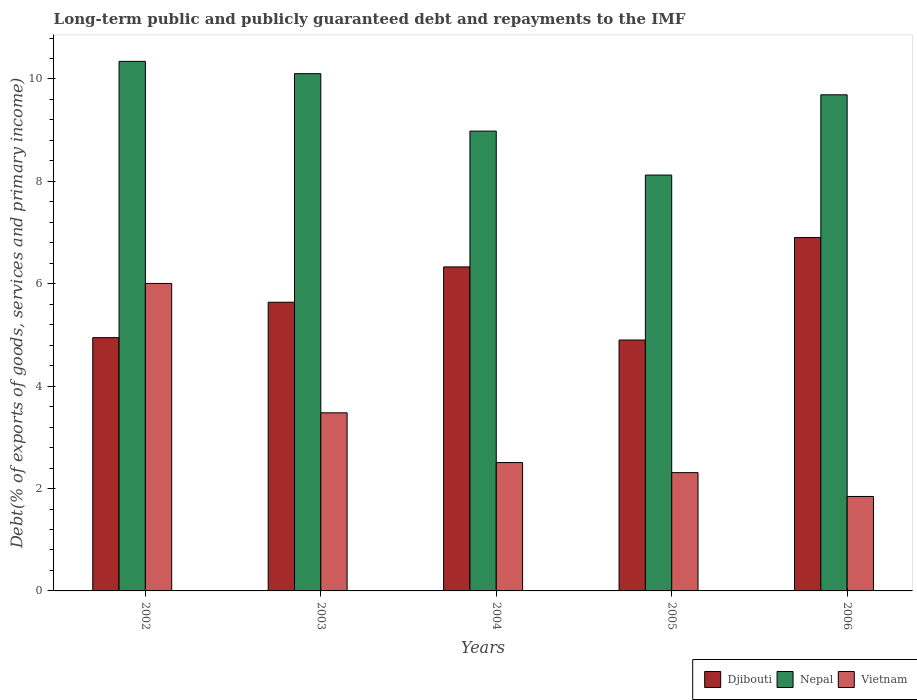How many different coloured bars are there?
Ensure brevity in your answer.  3. Are the number of bars per tick equal to the number of legend labels?
Make the answer very short. Yes. Are the number of bars on each tick of the X-axis equal?
Offer a terse response. Yes. How many bars are there on the 2nd tick from the left?
Your response must be concise. 3. How many bars are there on the 2nd tick from the right?
Provide a short and direct response. 3. What is the label of the 2nd group of bars from the left?
Make the answer very short. 2003. In how many cases, is the number of bars for a given year not equal to the number of legend labels?
Offer a very short reply. 0. What is the debt and repayments in Vietnam in 2005?
Your answer should be very brief. 2.31. Across all years, what is the maximum debt and repayments in Vietnam?
Your answer should be very brief. 6.01. Across all years, what is the minimum debt and repayments in Nepal?
Give a very brief answer. 8.12. What is the total debt and repayments in Vietnam in the graph?
Your answer should be very brief. 16.15. What is the difference between the debt and repayments in Nepal in 2003 and that in 2005?
Keep it short and to the point. 1.98. What is the difference between the debt and repayments in Nepal in 2002 and the debt and repayments in Vietnam in 2004?
Offer a terse response. 7.84. What is the average debt and repayments in Djibouti per year?
Make the answer very short. 5.74. In the year 2004, what is the difference between the debt and repayments in Nepal and debt and repayments in Vietnam?
Your answer should be very brief. 6.47. What is the ratio of the debt and repayments in Vietnam in 2003 to that in 2006?
Your answer should be very brief. 1.89. Is the debt and repayments in Nepal in 2002 less than that in 2006?
Make the answer very short. No. Is the difference between the debt and repayments in Nepal in 2005 and 2006 greater than the difference between the debt and repayments in Vietnam in 2005 and 2006?
Provide a succinct answer. No. What is the difference between the highest and the second highest debt and repayments in Djibouti?
Offer a terse response. 0.57. What is the difference between the highest and the lowest debt and repayments in Nepal?
Offer a terse response. 2.22. What does the 2nd bar from the left in 2002 represents?
Your answer should be compact. Nepal. What does the 1st bar from the right in 2004 represents?
Your answer should be very brief. Vietnam. Are all the bars in the graph horizontal?
Your response must be concise. No. How many years are there in the graph?
Ensure brevity in your answer.  5. Are the values on the major ticks of Y-axis written in scientific E-notation?
Your response must be concise. No. Does the graph contain grids?
Give a very brief answer. No. How many legend labels are there?
Your answer should be very brief. 3. What is the title of the graph?
Offer a very short reply. Long-term public and publicly guaranteed debt and repayments to the IMF. Does "Israel" appear as one of the legend labels in the graph?
Your answer should be very brief. No. What is the label or title of the X-axis?
Offer a terse response. Years. What is the label or title of the Y-axis?
Your answer should be very brief. Debt(% of exports of goods, services and primary income). What is the Debt(% of exports of goods, services and primary income) in Djibouti in 2002?
Your answer should be very brief. 4.95. What is the Debt(% of exports of goods, services and primary income) of Nepal in 2002?
Ensure brevity in your answer.  10.34. What is the Debt(% of exports of goods, services and primary income) of Vietnam in 2002?
Keep it short and to the point. 6.01. What is the Debt(% of exports of goods, services and primary income) in Djibouti in 2003?
Provide a succinct answer. 5.64. What is the Debt(% of exports of goods, services and primary income) in Nepal in 2003?
Offer a terse response. 10.1. What is the Debt(% of exports of goods, services and primary income) of Vietnam in 2003?
Keep it short and to the point. 3.48. What is the Debt(% of exports of goods, services and primary income) of Djibouti in 2004?
Provide a short and direct response. 6.33. What is the Debt(% of exports of goods, services and primary income) in Nepal in 2004?
Your answer should be very brief. 8.98. What is the Debt(% of exports of goods, services and primary income) in Vietnam in 2004?
Your response must be concise. 2.51. What is the Debt(% of exports of goods, services and primary income) of Djibouti in 2005?
Make the answer very short. 4.9. What is the Debt(% of exports of goods, services and primary income) in Nepal in 2005?
Your answer should be compact. 8.12. What is the Debt(% of exports of goods, services and primary income) in Vietnam in 2005?
Your answer should be compact. 2.31. What is the Debt(% of exports of goods, services and primary income) of Djibouti in 2006?
Your answer should be very brief. 6.9. What is the Debt(% of exports of goods, services and primary income) in Nepal in 2006?
Your answer should be very brief. 9.69. What is the Debt(% of exports of goods, services and primary income) of Vietnam in 2006?
Offer a terse response. 1.84. Across all years, what is the maximum Debt(% of exports of goods, services and primary income) in Djibouti?
Offer a terse response. 6.9. Across all years, what is the maximum Debt(% of exports of goods, services and primary income) of Nepal?
Offer a very short reply. 10.34. Across all years, what is the maximum Debt(% of exports of goods, services and primary income) in Vietnam?
Your response must be concise. 6.01. Across all years, what is the minimum Debt(% of exports of goods, services and primary income) in Djibouti?
Keep it short and to the point. 4.9. Across all years, what is the minimum Debt(% of exports of goods, services and primary income) of Nepal?
Ensure brevity in your answer.  8.12. Across all years, what is the minimum Debt(% of exports of goods, services and primary income) of Vietnam?
Make the answer very short. 1.84. What is the total Debt(% of exports of goods, services and primary income) in Djibouti in the graph?
Keep it short and to the point. 28.72. What is the total Debt(% of exports of goods, services and primary income) in Nepal in the graph?
Keep it short and to the point. 47.24. What is the total Debt(% of exports of goods, services and primary income) of Vietnam in the graph?
Keep it short and to the point. 16.15. What is the difference between the Debt(% of exports of goods, services and primary income) in Djibouti in 2002 and that in 2003?
Offer a terse response. -0.69. What is the difference between the Debt(% of exports of goods, services and primary income) in Nepal in 2002 and that in 2003?
Your response must be concise. 0.24. What is the difference between the Debt(% of exports of goods, services and primary income) in Vietnam in 2002 and that in 2003?
Your answer should be compact. 2.53. What is the difference between the Debt(% of exports of goods, services and primary income) in Djibouti in 2002 and that in 2004?
Offer a terse response. -1.38. What is the difference between the Debt(% of exports of goods, services and primary income) in Nepal in 2002 and that in 2004?
Provide a short and direct response. 1.36. What is the difference between the Debt(% of exports of goods, services and primary income) in Vietnam in 2002 and that in 2004?
Your answer should be compact. 3.5. What is the difference between the Debt(% of exports of goods, services and primary income) of Djibouti in 2002 and that in 2005?
Offer a terse response. 0.05. What is the difference between the Debt(% of exports of goods, services and primary income) of Nepal in 2002 and that in 2005?
Your response must be concise. 2.22. What is the difference between the Debt(% of exports of goods, services and primary income) of Vietnam in 2002 and that in 2005?
Your answer should be very brief. 3.7. What is the difference between the Debt(% of exports of goods, services and primary income) in Djibouti in 2002 and that in 2006?
Your response must be concise. -1.96. What is the difference between the Debt(% of exports of goods, services and primary income) in Nepal in 2002 and that in 2006?
Ensure brevity in your answer.  0.65. What is the difference between the Debt(% of exports of goods, services and primary income) in Vietnam in 2002 and that in 2006?
Your response must be concise. 4.16. What is the difference between the Debt(% of exports of goods, services and primary income) in Djibouti in 2003 and that in 2004?
Your response must be concise. -0.69. What is the difference between the Debt(% of exports of goods, services and primary income) in Nepal in 2003 and that in 2004?
Provide a succinct answer. 1.12. What is the difference between the Debt(% of exports of goods, services and primary income) in Vietnam in 2003 and that in 2004?
Your answer should be very brief. 0.97. What is the difference between the Debt(% of exports of goods, services and primary income) in Djibouti in 2003 and that in 2005?
Offer a terse response. 0.74. What is the difference between the Debt(% of exports of goods, services and primary income) of Nepal in 2003 and that in 2005?
Provide a short and direct response. 1.98. What is the difference between the Debt(% of exports of goods, services and primary income) of Vietnam in 2003 and that in 2005?
Offer a very short reply. 1.17. What is the difference between the Debt(% of exports of goods, services and primary income) in Djibouti in 2003 and that in 2006?
Provide a succinct answer. -1.26. What is the difference between the Debt(% of exports of goods, services and primary income) in Nepal in 2003 and that in 2006?
Your answer should be very brief. 0.41. What is the difference between the Debt(% of exports of goods, services and primary income) of Vietnam in 2003 and that in 2006?
Ensure brevity in your answer.  1.63. What is the difference between the Debt(% of exports of goods, services and primary income) in Djibouti in 2004 and that in 2005?
Your answer should be very brief. 1.43. What is the difference between the Debt(% of exports of goods, services and primary income) of Nepal in 2004 and that in 2005?
Make the answer very short. 0.86. What is the difference between the Debt(% of exports of goods, services and primary income) in Vietnam in 2004 and that in 2005?
Provide a short and direct response. 0.2. What is the difference between the Debt(% of exports of goods, services and primary income) in Djibouti in 2004 and that in 2006?
Give a very brief answer. -0.57. What is the difference between the Debt(% of exports of goods, services and primary income) of Nepal in 2004 and that in 2006?
Offer a very short reply. -0.71. What is the difference between the Debt(% of exports of goods, services and primary income) of Vietnam in 2004 and that in 2006?
Your answer should be compact. 0.66. What is the difference between the Debt(% of exports of goods, services and primary income) in Djibouti in 2005 and that in 2006?
Give a very brief answer. -2. What is the difference between the Debt(% of exports of goods, services and primary income) in Nepal in 2005 and that in 2006?
Your response must be concise. -1.57. What is the difference between the Debt(% of exports of goods, services and primary income) of Vietnam in 2005 and that in 2006?
Your answer should be very brief. 0.47. What is the difference between the Debt(% of exports of goods, services and primary income) of Djibouti in 2002 and the Debt(% of exports of goods, services and primary income) of Nepal in 2003?
Ensure brevity in your answer.  -5.16. What is the difference between the Debt(% of exports of goods, services and primary income) of Djibouti in 2002 and the Debt(% of exports of goods, services and primary income) of Vietnam in 2003?
Provide a short and direct response. 1.47. What is the difference between the Debt(% of exports of goods, services and primary income) in Nepal in 2002 and the Debt(% of exports of goods, services and primary income) in Vietnam in 2003?
Provide a succinct answer. 6.87. What is the difference between the Debt(% of exports of goods, services and primary income) in Djibouti in 2002 and the Debt(% of exports of goods, services and primary income) in Nepal in 2004?
Your answer should be compact. -4.03. What is the difference between the Debt(% of exports of goods, services and primary income) in Djibouti in 2002 and the Debt(% of exports of goods, services and primary income) in Vietnam in 2004?
Ensure brevity in your answer.  2.44. What is the difference between the Debt(% of exports of goods, services and primary income) in Nepal in 2002 and the Debt(% of exports of goods, services and primary income) in Vietnam in 2004?
Make the answer very short. 7.84. What is the difference between the Debt(% of exports of goods, services and primary income) of Djibouti in 2002 and the Debt(% of exports of goods, services and primary income) of Nepal in 2005?
Ensure brevity in your answer.  -3.18. What is the difference between the Debt(% of exports of goods, services and primary income) in Djibouti in 2002 and the Debt(% of exports of goods, services and primary income) in Vietnam in 2005?
Provide a succinct answer. 2.64. What is the difference between the Debt(% of exports of goods, services and primary income) of Nepal in 2002 and the Debt(% of exports of goods, services and primary income) of Vietnam in 2005?
Give a very brief answer. 8.03. What is the difference between the Debt(% of exports of goods, services and primary income) of Djibouti in 2002 and the Debt(% of exports of goods, services and primary income) of Nepal in 2006?
Offer a very short reply. -4.74. What is the difference between the Debt(% of exports of goods, services and primary income) of Djibouti in 2002 and the Debt(% of exports of goods, services and primary income) of Vietnam in 2006?
Offer a very short reply. 3.1. What is the difference between the Debt(% of exports of goods, services and primary income) of Nepal in 2002 and the Debt(% of exports of goods, services and primary income) of Vietnam in 2006?
Your response must be concise. 8.5. What is the difference between the Debt(% of exports of goods, services and primary income) in Djibouti in 2003 and the Debt(% of exports of goods, services and primary income) in Nepal in 2004?
Provide a short and direct response. -3.34. What is the difference between the Debt(% of exports of goods, services and primary income) of Djibouti in 2003 and the Debt(% of exports of goods, services and primary income) of Vietnam in 2004?
Provide a succinct answer. 3.13. What is the difference between the Debt(% of exports of goods, services and primary income) in Nepal in 2003 and the Debt(% of exports of goods, services and primary income) in Vietnam in 2004?
Offer a very short reply. 7.6. What is the difference between the Debt(% of exports of goods, services and primary income) in Djibouti in 2003 and the Debt(% of exports of goods, services and primary income) in Nepal in 2005?
Provide a succinct answer. -2.48. What is the difference between the Debt(% of exports of goods, services and primary income) in Djibouti in 2003 and the Debt(% of exports of goods, services and primary income) in Vietnam in 2005?
Ensure brevity in your answer.  3.33. What is the difference between the Debt(% of exports of goods, services and primary income) in Nepal in 2003 and the Debt(% of exports of goods, services and primary income) in Vietnam in 2005?
Provide a succinct answer. 7.79. What is the difference between the Debt(% of exports of goods, services and primary income) in Djibouti in 2003 and the Debt(% of exports of goods, services and primary income) in Nepal in 2006?
Provide a short and direct response. -4.05. What is the difference between the Debt(% of exports of goods, services and primary income) in Djibouti in 2003 and the Debt(% of exports of goods, services and primary income) in Vietnam in 2006?
Provide a short and direct response. 3.79. What is the difference between the Debt(% of exports of goods, services and primary income) of Nepal in 2003 and the Debt(% of exports of goods, services and primary income) of Vietnam in 2006?
Your response must be concise. 8.26. What is the difference between the Debt(% of exports of goods, services and primary income) of Djibouti in 2004 and the Debt(% of exports of goods, services and primary income) of Nepal in 2005?
Provide a short and direct response. -1.79. What is the difference between the Debt(% of exports of goods, services and primary income) in Djibouti in 2004 and the Debt(% of exports of goods, services and primary income) in Vietnam in 2005?
Provide a short and direct response. 4.02. What is the difference between the Debt(% of exports of goods, services and primary income) of Nepal in 2004 and the Debt(% of exports of goods, services and primary income) of Vietnam in 2005?
Provide a short and direct response. 6.67. What is the difference between the Debt(% of exports of goods, services and primary income) in Djibouti in 2004 and the Debt(% of exports of goods, services and primary income) in Nepal in 2006?
Your answer should be compact. -3.36. What is the difference between the Debt(% of exports of goods, services and primary income) in Djibouti in 2004 and the Debt(% of exports of goods, services and primary income) in Vietnam in 2006?
Keep it short and to the point. 4.48. What is the difference between the Debt(% of exports of goods, services and primary income) in Nepal in 2004 and the Debt(% of exports of goods, services and primary income) in Vietnam in 2006?
Keep it short and to the point. 7.14. What is the difference between the Debt(% of exports of goods, services and primary income) of Djibouti in 2005 and the Debt(% of exports of goods, services and primary income) of Nepal in 2006?
Your answer should be very brief. -4.79. What is the difference between the Debt(% of exports of goods, services and primary income) of Djibouti in 2005 and the Debt(% of exports of goods, services and primary income) of Vietnam in 2006?
Make the answer very short. 3.06. What is the difference between the Debt(% of exports of goods, services and primary income) of Nepal in 2005 and the Debt(% of exports of goods, services and primary income) of Vietnam in 2006?
Your answer should be very brief. 6.28. What is the average Debt(% of exports of goods, services and primary income) in Djibouti per year?
Ensure brevity in your answer.  5.74. What is the average Debt(% of exports of goods, services and primary income) of Nepal per year?
Provide a succinct answer. 9.45. What is the average Debt(% of exports of goods, services and primary income) of Vietnam per year?
Your response must be concise. 3.23. In the year 2002, what is the difference between the Debt(% of exports of goods, services and primary income) in Djibouti and Debt(% of exports of goods, services and primary income) in Nepal?
Keep it short and to the point. -5.4. In the year 2002, what is the difference between the Debt(% of exports of goods, services and primary income) in Djibouti and Debt(% of exports of goods, services and primary income) in Vietnam?
Provide a short and direct response. -1.06. In the year 2002, what is the difference between the Debt(% of exports of goods, services and primary income) of Nepal and Debt(% of exports of goods, services and primary income) of Vietnam?
Offer a terse response. 4.34. In the year 2003, what is the difference between the Debt(% of exports of goods, services and primary income) of Djibouti and Debt(% of exports of goods, services and primary income) of Nepal?
Offer a terse response. -4.46. In the year 2003, what is the difference between the Debt(% of exports of goods, services and primary income) of Djibouti and Debt(% of exports of goods, services and primary income) of Vietnam?
Keep it short and to the point. 2.16. In the year 2003, what is the difference between the Debt(% of exports of goods, services and primary income) of Nepal and Debt(% of exports of goods, services and primary income) of Vietnam?
Provide a short and direct response. 6.62. In the year 2004, what is the difference between the Debt(% of exports of goods, services and primary income) in Djibouti and Debt(% of exports of goods, services and primary income) in Nepal?
Keep it short and to the point. -2.65. In the year 2004, what is the difference between the Debt(% of exports of goods, services and primary income) in Djibouti and Debt(% of exports of goods, services and primary income) in Vietnam?
Your answer should be very brief. 3.82. In the year 2004, what is the difference between the Debt(% of exports of goods, services and primary income) of Nepal and Debt(% of exports of goods, services and primary income) of Vietnam?
Offer a terse response. 6.47. In the year 2005, what is the difference between the Debt(% of exports of goods, services and primary income) in Djibouti and Debt(% of exports of goods, services and primary income) in Nepal?
Give a very brief answer. -3.22. In the year 2005, what is the difference between the Debt(% of exports of goods, services and primary income) in Djibouti and Debt(% of exports of goods, services and primary income) in Vietnam?
Provide a short and direct response. 2.59. In the year 2005, what is the difference between the Debt(% of exports of goods, services and primary income) in Nepal and Debt(% of exports of goods, services and primary income) in Vietnam?
Make the answer very short. 5.81. In the year 2006, what is the difference between the Debt(% of exports of goods, services and primary income) of Djibouti and Debt(% of exports of goods, services and primary income) of Nepal?
Offer a very short reply. -2.79. In the year 2006, what is the difference between the Debt(% of exports of goods, services and primary income) of Djibouti and Debt(% of exports of goods, services and primary income) of Vietnam?
Keep it short and to the point. 5.06. In the year 2006, what is the difference between the Debt(% of exports of goods, services and primary income) in Nepal and Debt(% of exports of goods, services and primary income) in Vietnam?
Your answer should be compact. 7.85. What is the ratio of the Debt(% of exports of goods, services and primary income) in Djibouti in 2002 to that in 2003?
Your answer should be compact. 0.88. What is the ratio of the Debt(% of exports of goods, services and primary income) of Nepal in 2002 to that in 2003?
Ensure brevity in your answer.  1.02. What is the ratio of the Debt(% of exports of goods, services and primary income) of Vietnam in 2002 to that in 2003?
Give a very brief answer. 1.73. What is the ratio of the Debt(% of exports of goods, services and primary income) of Djibouti in 2002 to that in 2004?
Your response must be concise. 0.78. What is the ratio of the Debt(% of exports of goods, services and primary income) of Nepal in 2002 to that in 2004?
Offer a terse response. 1.15. What is the ratio of the Debt(% of exports of goods, services and primary income) of Vietnam in 2002 to that in 2004?
Ensure brevity in your answer.  2.4. What is the ratio of the Debt(% of exports of goods, services and primary income) of Djibouti in 2002 to that in 2005?
Ensure brevity in your answer.  1.01. What is the ratio of the Debt(% of exports of goods, services and primary income) in Nepal in 2002 to that in 2005?
Your response must be concise. 1.27. What is the ratio of the Debt(% of exports of goods, services and primary income) in Vietnam in 2002 to that in 2005?
Make the answer very short. 2.6. What is the ratio of the Debt(% of exports of goods, services and primary income) of Djibouti in 2002 to that in 2006?
Make the answer very short. 0.72. What is the ratio of the Debt(% of exports of goods, services and primary income) in Nepal in 2002 to that in 2006?
Provide a short and direct response. 1.07. What is the ratio of the Debt(% of exports of goods, services and primary income) of Vietnam in 2002 to that in 2006?
Offer a terse response. 3.26. What is the ratio of the Debt(% of exports of goods, services and primary income) in Djibouti in 2003 to that in 2004?
Offer a terse response. 0.89. What is the ratio of the Debt(% of exports of goods, services and primary income) in Nepal in 2003 to that in 2004?
Offer a terse response. 1.12. What is the ratio of the Debt(% of exports of goods, services and primary income) of Vietnam in 2003 to that in 2004?
Give a very brief answer. 1.39. What is the ratio of the Debt(% of exports of goods, services and primary income) of Djibouti in 2003 to that in 2005?
Provide a short and direct response. 1.15. What is the ratio of the Debt(% of exports of goods, services and primary income) in Nepal in 2003 to that in 2005?
Give a very brief answer. 1.24. What is the ratio of the Debt(% of exports of goods, services and primary income) in Vietnam in 2003 to that in 2005?
Offer a very short reply. 1.51. What is the ratio of the Debt(% of exports of goods, services and primary income) in Djibouti in 2003 to that in 2006?
Keep it short and to the point. 0.82. What is the ratio of the Debt(% of exports of goods, services and primary income) of Nepal in 2003 to that in 2006?
Ensure brevity in your answer.  1.04. What is the ratio of the Debt(% of exports of goods, services and primary income) of Vietnam in 2003 to that in 2006?
Provide a short and direct response. 1.89. What is the ratio of the Debt(% of exports of goods, services and primary income) in Djibouti in 2004 to that in 2005?
Ensure brevity in your answer.  1.29. What is the ratio of the Debt(% of exports of goods, services and primary income) in Nepal in 2004 to that in 2005?
Provide a succinct answer. 1.11. What is the ratio of the Debt(% of exports of goods, services and primary income) of Vietnam in 2004 to that in 2005?
Your answer should be very brief. 1.09. What is the ratio of the Debt(% of exports of goods, services and primary income) in Djibouti in 2004 to that in 2006?
Your response must be concise. 0.92. What is the ratio of the Debt(% of exports of goods, services and primary income) of Nepal in 2004 to that in 2006?
Your answer should be very brief. 0.93. What is the ratio of the Debt(% of exports of goods, services and primary income) in Vietnam in 2004 to that in 2006?
Make the answer very short. 1.36. What is the ratio of the Debt(% of exports of goods, services and primary income) of Djibouti in 2005 to that in 2006?
Provide a short and direct response. 0.71. What is the ratio of the Debt(% of exports of goods, services and primary income) of Nepal in 2005 to that in 2006?
Your response must be concise. 0.84. What is the ratio of the Debt(% of exports of goods, services and primary income) in Vietnam in 2005 to that in 2006?
Provide a short and direct response. 1.25. What is the difference between the highest and the second highest Debt(% of exports of goods, services and primary income) in Djibouti?
Your response must be concise. 0.57. What is the difference between the highest and the second highest Debt(% of exports of goods, services and primary income) of Nepal?
Provide a short and direct response. 0.24. What is the difference between the highest and the second highest Debt(% of exports of goods, services and primary income) in Vietnam?
Ensure brevity in your answer.  2.53. What is the difference between the highest and the lowest Debt(% of exports of goods, services and primary income) in Djibouti?
Give a very brief answer. 2. What is the difference between the highest and the lowest Debt(% of exports of goods, services and primary income) of Nepal?
Your response must be concise. 2.22. What is the difference between the highest and the lowest Debt(% of exports of goods, services and primary income) of Vietnam?
Keep it short and to the point. 4.16. 